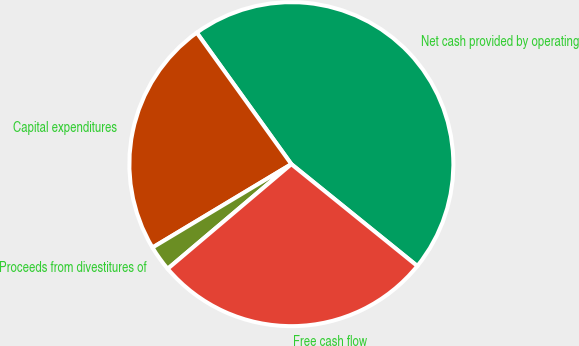<chart> <loc_0><loc_0><loc_500><loc_500><pie_chart><fcel>Net cash provided by operating<fcel>Capital expenditures<fcel>Proceeds from divestitures of<fcel>Free cash flow<nl><fcel>45.75%<fcel>23.68%<fcel>2.57%<fcel>28.0%<nl></chart> 